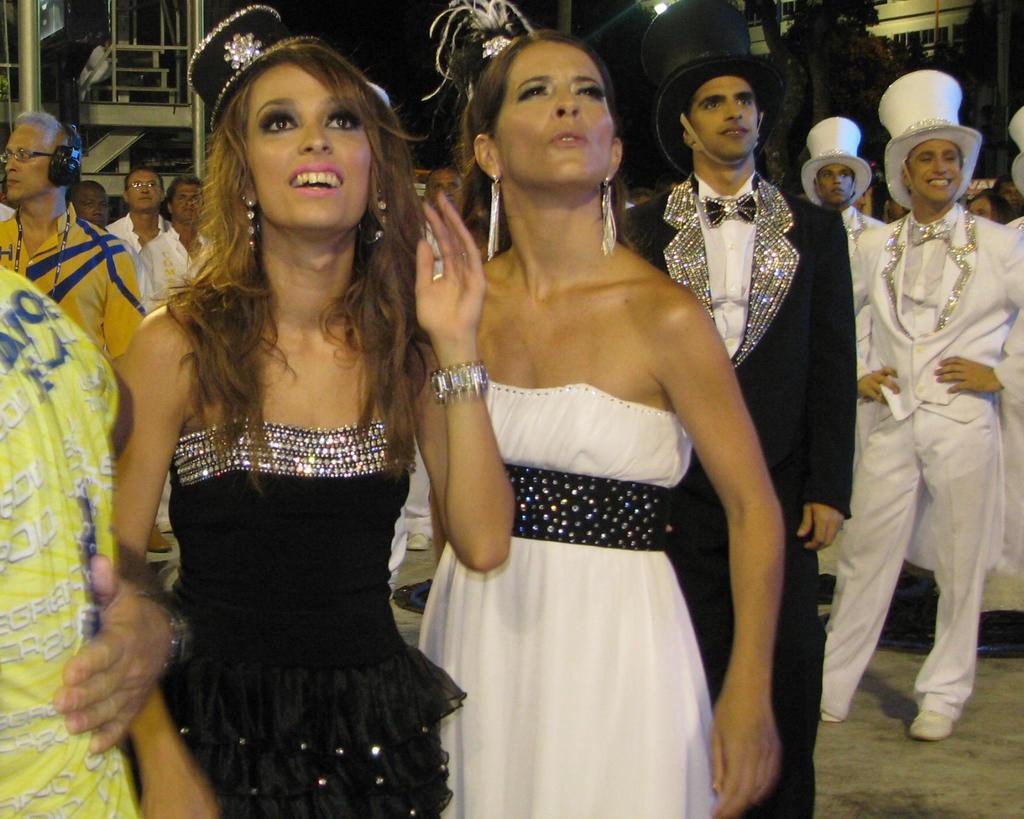Can you describe this image briefly? In this picture there are people. In the foreground there are two women in black and white dress. In the center there are men mostly in suits and hats. In the background there are building, trees and staircase. On the left there is a person with headphones. 